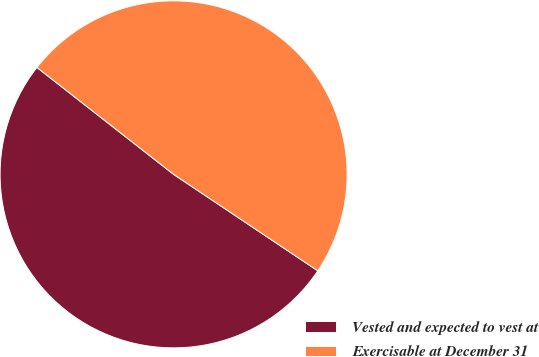Convert chart. <chart><loc_0><loc_0><loc_500><loc_500><pie_chart><fcel>Vested and expected to vest at<fcel>Exercisable at December 31<nl><fcel>51.18%<fcel>48.82%<nl></chart> 